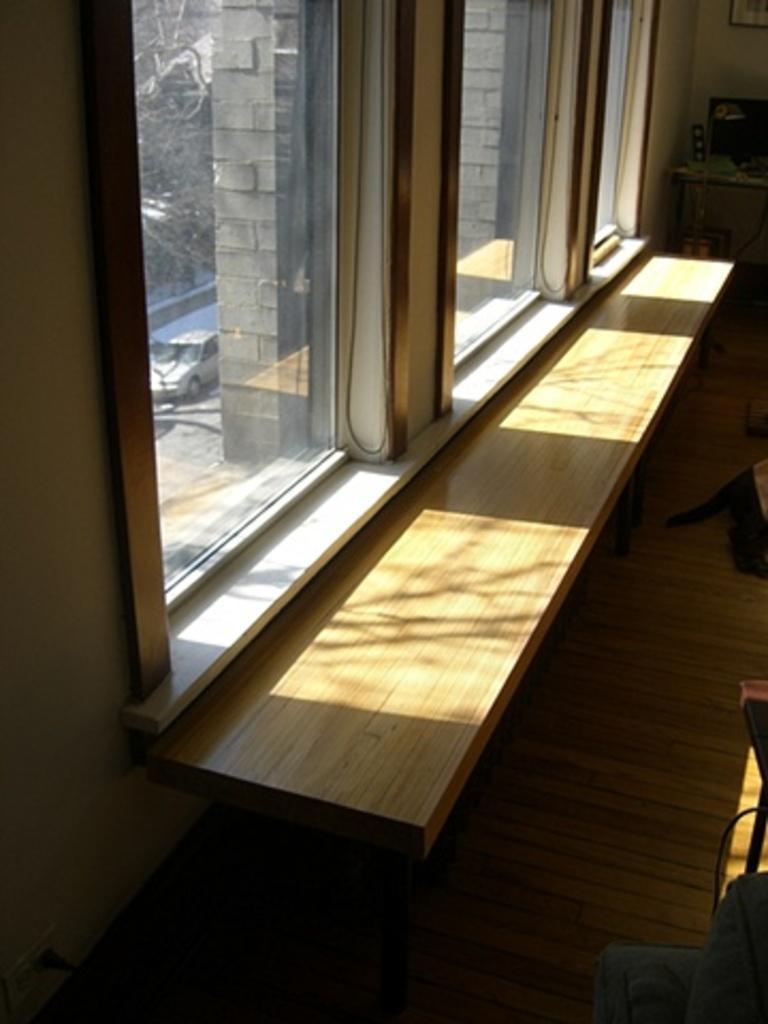In one or two sentences, can you explain what this image depicts? There is a window and through the window, a bright sunlight is falling on a shelf before the window. 